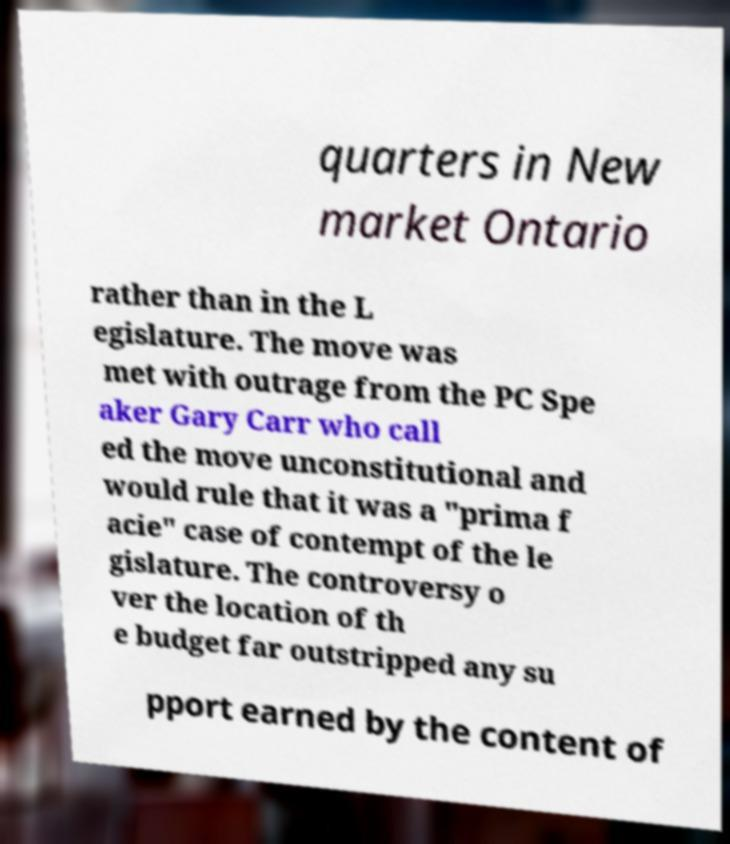Could you extract and type out the text from this image? quarters in New market Ontario rather than in the L egislature. The move was met with outrage from the PC Spe aker Gary Carr who call ed the move unconstitutional and would rule that it was a "prima f acie" case of contempt of the le gislature. The controversy o ver the location of th e budget far outstripped any su pport earned by the content of 